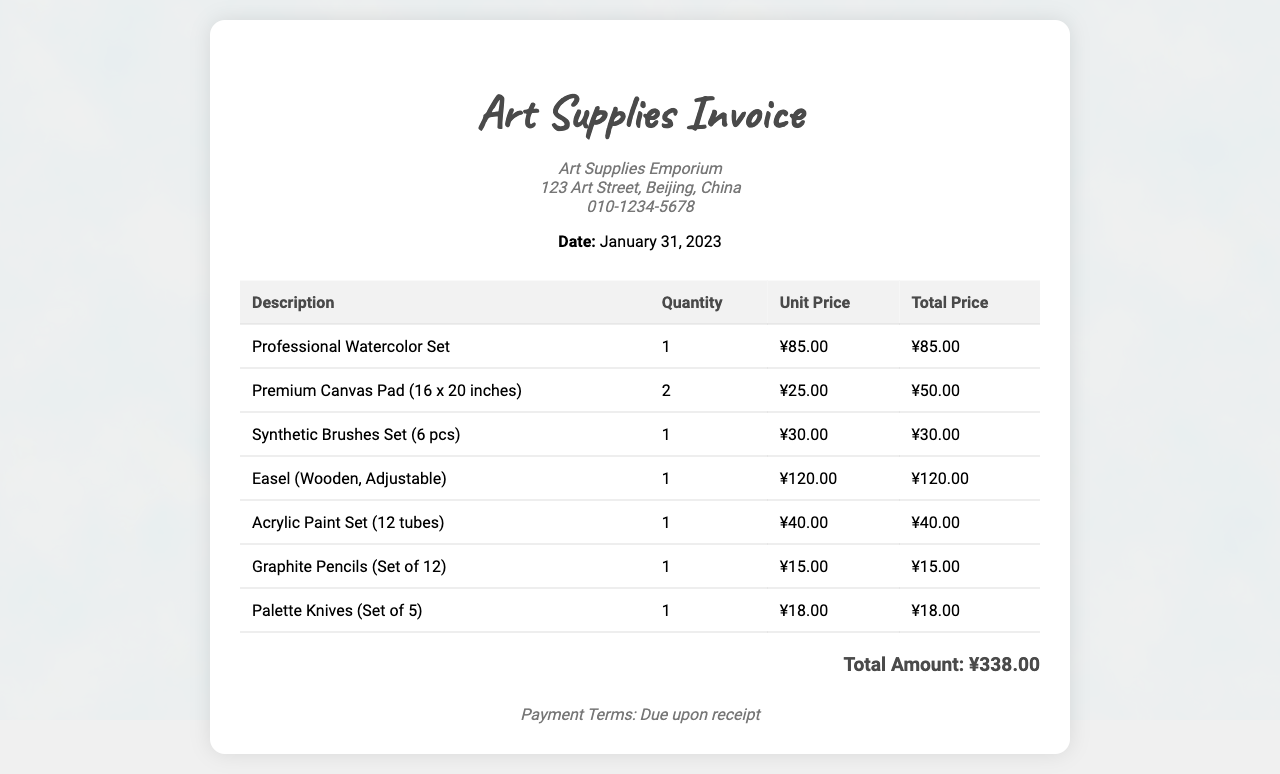What is the date of the invoice? The date mentioned in the header of the invoice is January 31, 2023.
Answer: January 31, 2023 Who is the supplier of the art supplies? The supplier listed in the document is Art Supplies Emporium.
Answer: Art Supplies Emporium How many items are listed in the invoice? The invoice contains a total of 7 different items listed in the table.
Answer: 7 What is the unit price of the Professional Watercolor Set? The unit price for the Professional Watercolor Set is stated as ¥85.00.
Answer: ¥85.00 What is the total amount due? The total amount due is provided at the bottom of the invoice, which sums up all items.
Answer: ¥338.00 What type of easel is mentioned in the invoice? The invoice specifies that the easel is a Wooden, Adjustable type.
Answer: Wooden, Adjustable What is the quantity of Premium Canvas Pad purchased? The quantity of the Premium Canvas Pad purchased is recorded as 2.
Answer: 2 How much does the set of Palette Knives cost? The total cost for the Palette Knives (Set of 5) is given as ¥18.00.
Answer: ¥18.00 What are the payment terms stated in the invoice? The payment terms indicated on the invoice are due upon receipt.
Answer: Due upon receipt 